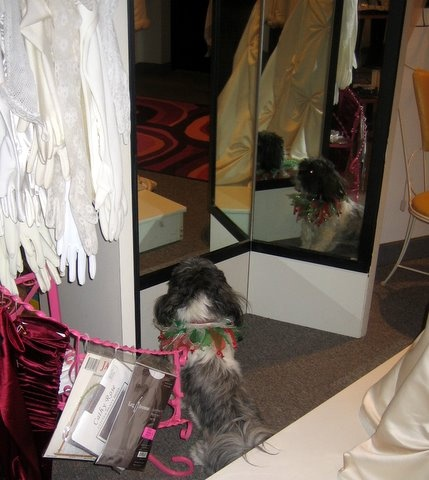Describe the objects in this image and their specific colors. I can see dog in lightgray, gray, black, and maroon tones, dog in lightgray, black, gray, and maroon tones, book in lightgray, gray, black, and darkgray tones, chair in lightgray, gray, and maroon tones, and book in lightgray and darkgray tones in this image. 